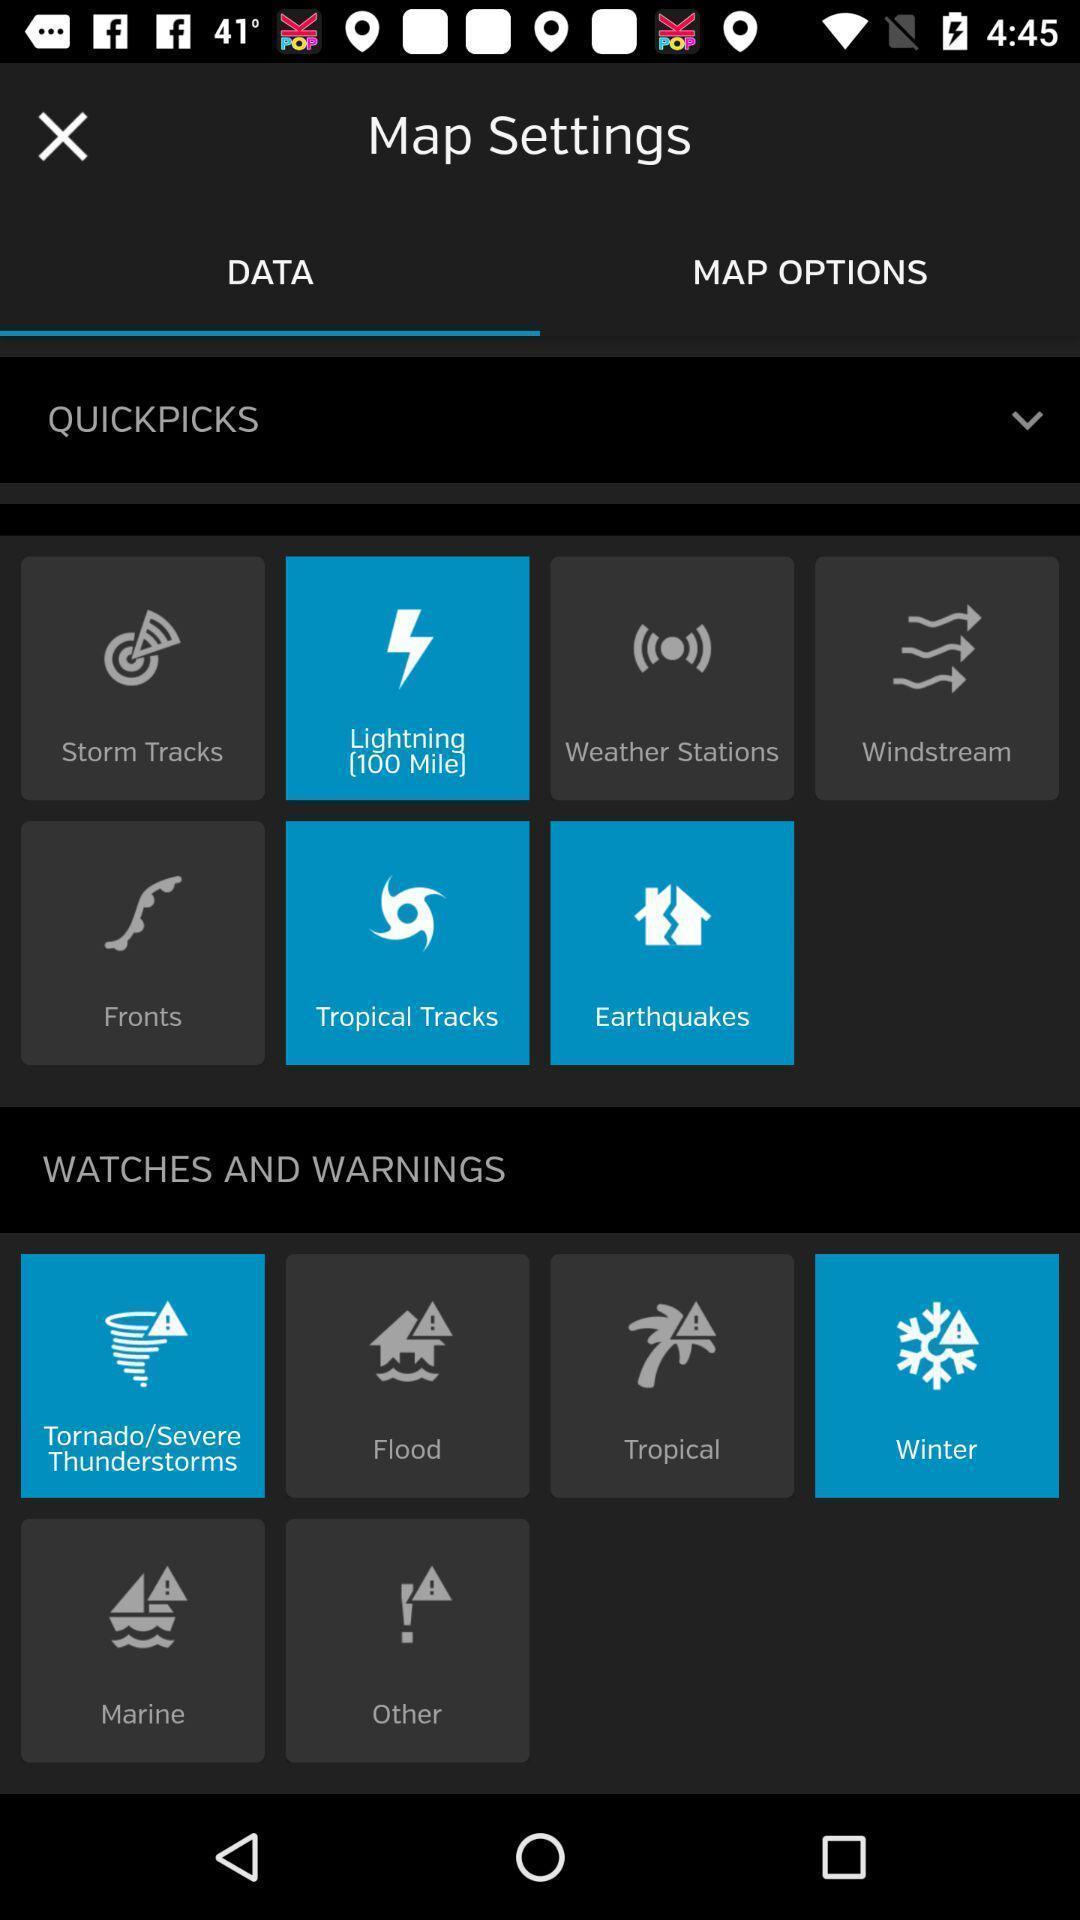Provide a textual representation of this image. Screen displaying settings for map. 